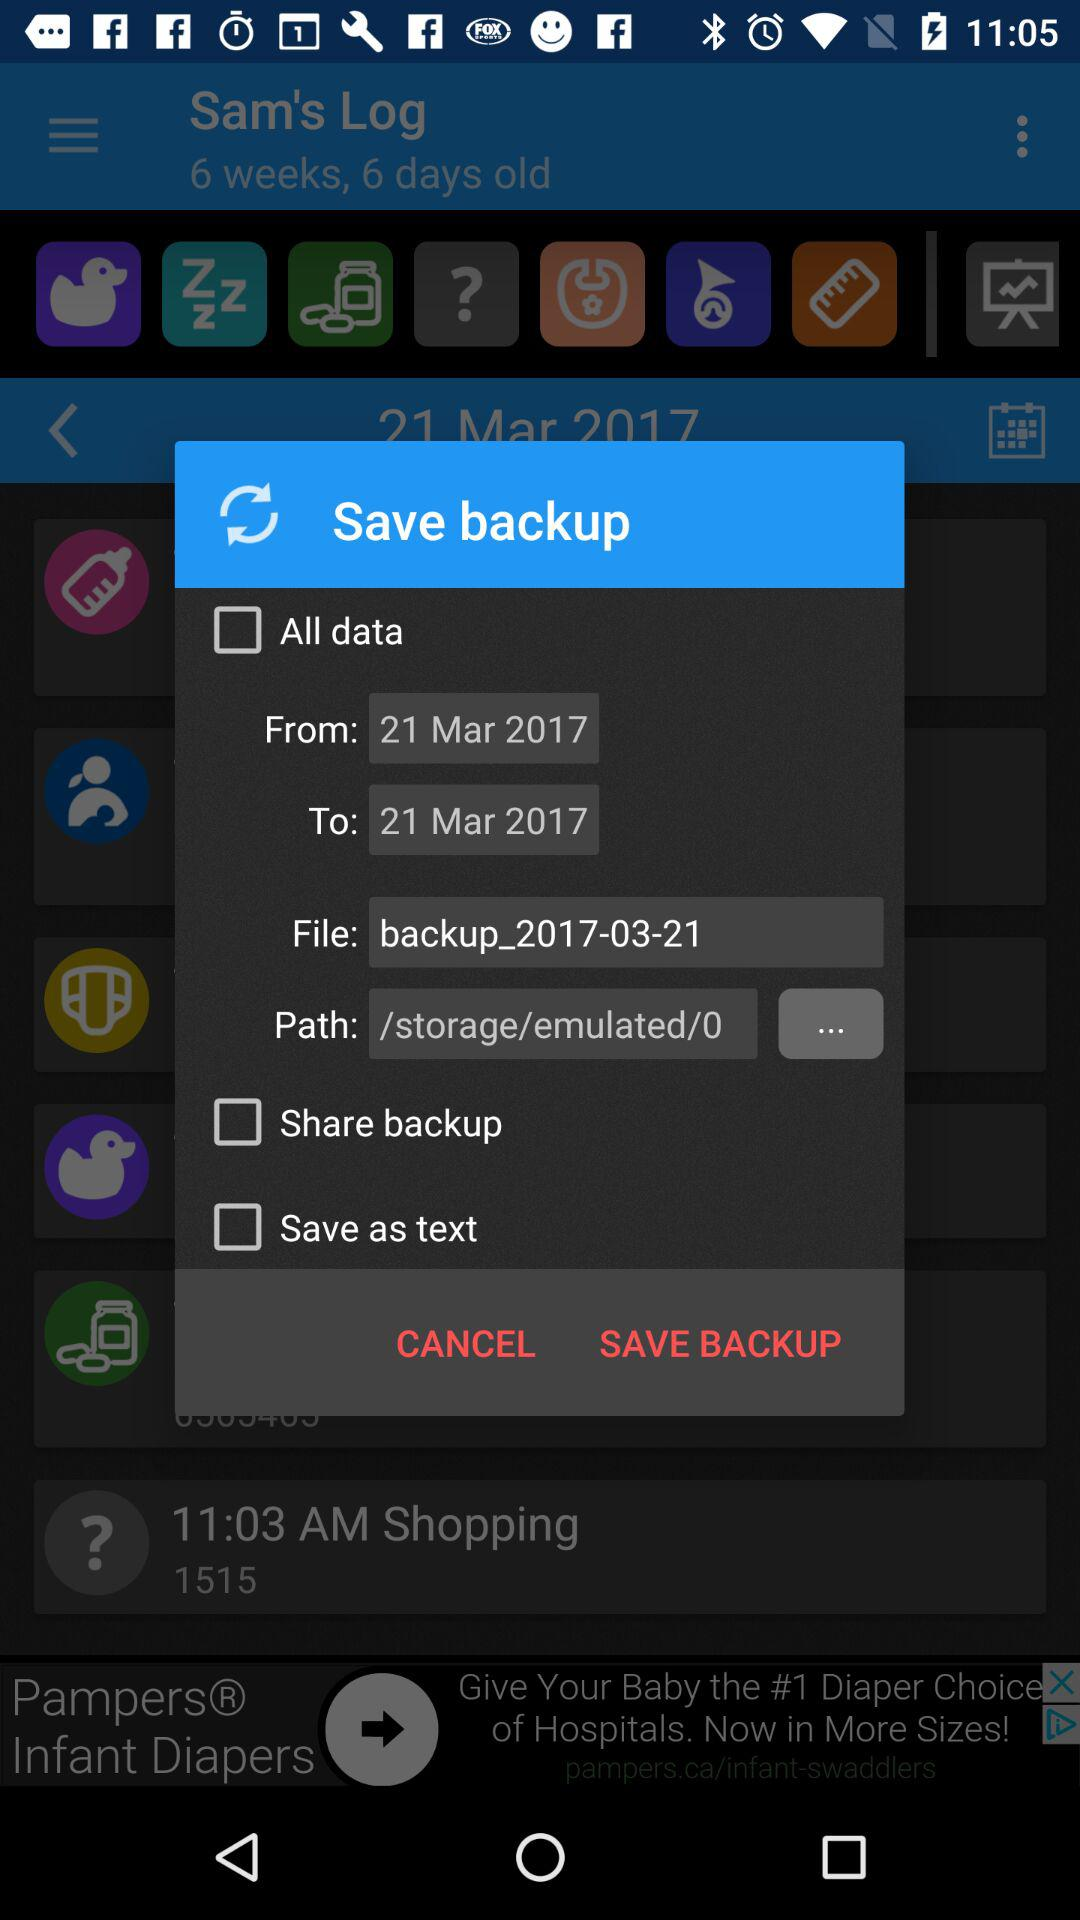What is the name of the file? The name of the file is "backup_2017-03-21". 